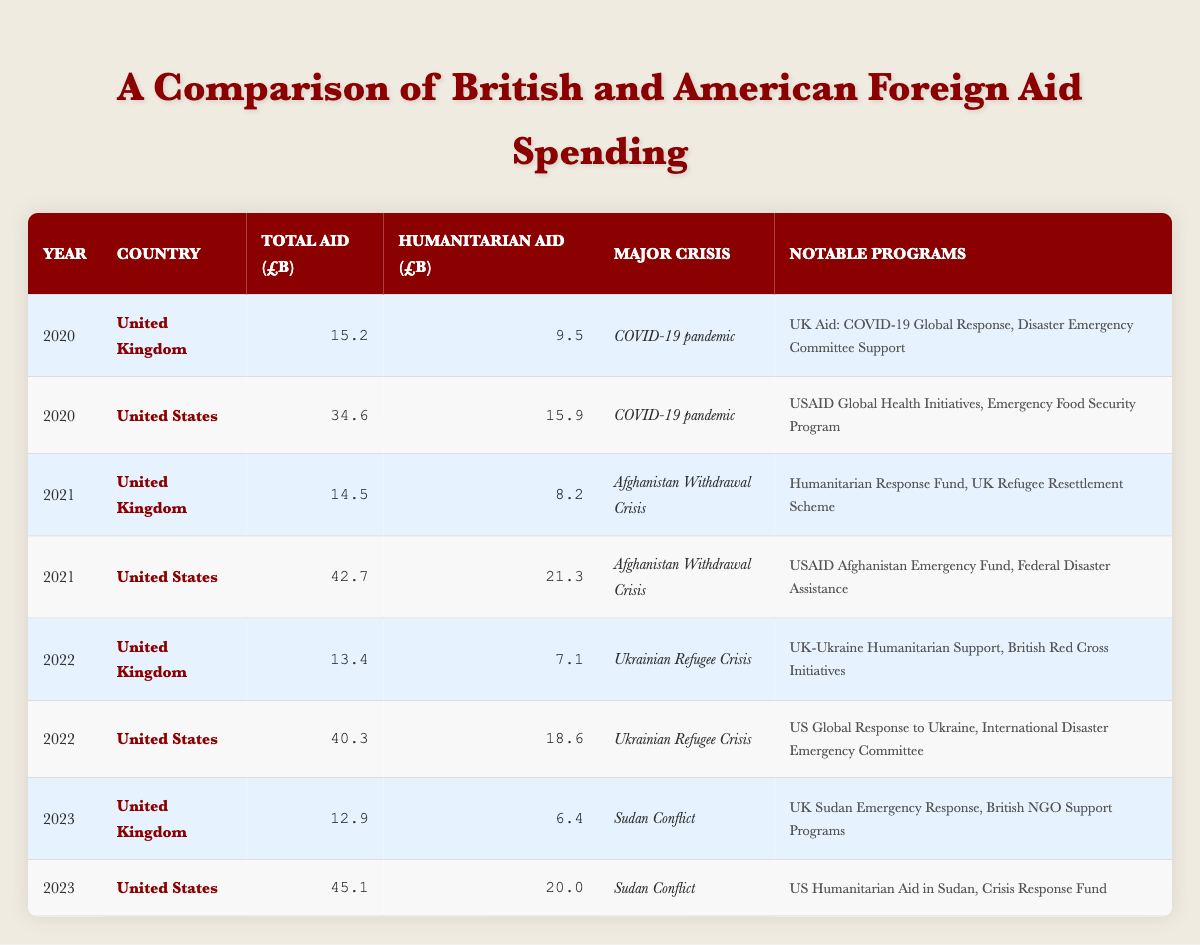What was the total aid spending by the United Kingdom in 2021? The table shows the row for the United Kingdom in 2021, where the total aid spending is listed as 14.5 billion pounds.
Answer: 14.5 billion pounds Which country had a higher humanitarian aid spending in 2020? The table can be examined for the humanitarian aid spending in 2020: the United Kingdom spent 9.5 billion pounds, while the United States spent 15.9 billion pounds. Therefore, the United States had higher humanitarian aid spending.
Answer: United States What is the difference in total aid spending between the United States and the United Kingdom in 2022? In 2022, the United States spent 40.3 billion pounds and the United Kingdom spent 13.4 billion pounds. To find the difference: 40.3 - 13.4 = 26.9 billion pounds.
Answer: 26.9 billion pounds Did the United Kingdom spend more humanitarian aid in 2022 compared to 2021? In 2021, the UK's humanitarian aid spending was 8.2 billion pounds, while in 2022 it was 7.1 billion pounds. Since 7.1 is less than 8.2, the answer is no.
Answer: No What was the average humanitarian aid spending by the United Kingdom over the years 2020 to 2023? First, we sum up the humanitarian aid spending for 2020 (9.5), 2021 (8.2), 2022 (7.1), and 2023 (6.4): 9.5 + 8.2 + 7.1 + 6.4 = 31.2 billion pounds. Then, we divide by the number of years (4): 31.2 / 4 = 7.8 billion pounds.
Answer: 7.8 billion pounds In which year did the United States spend the most on total aid? By reviewing the total aid spending for the United States, the values are 34.6 billion pounds in 2020, 42.7 in 2021, 40.3 billion in 2022, and 45.1 billion in 2023. The highest value is in 2023 with 45.1 billion pounds.
Answer: 2023 